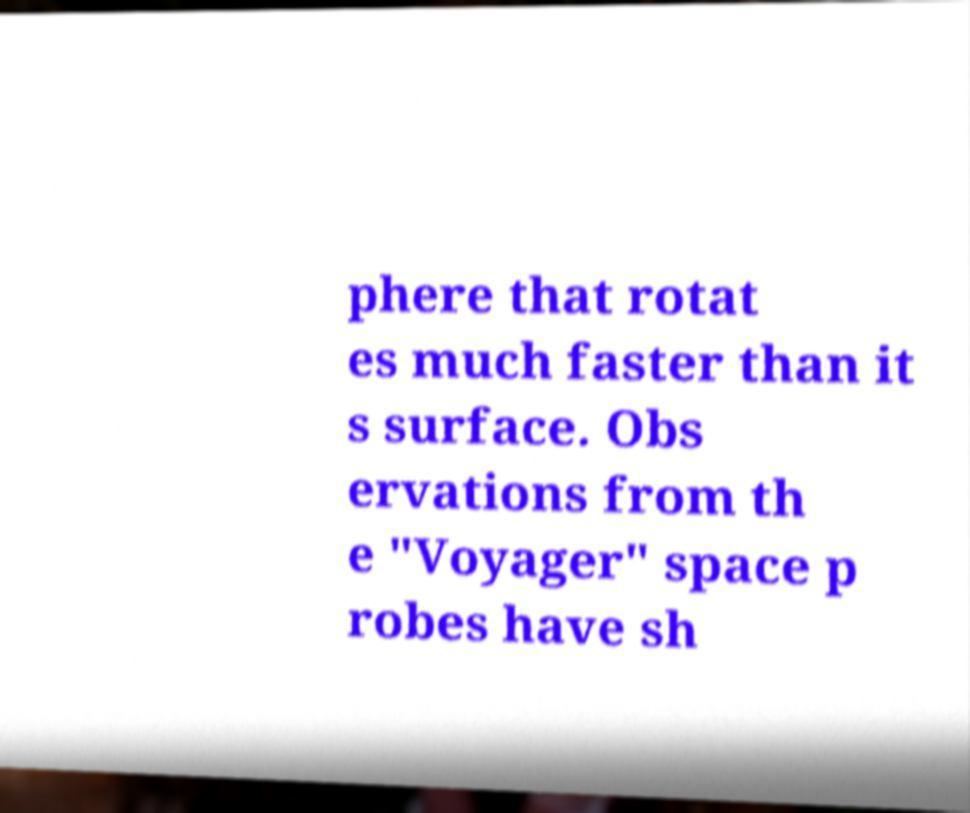Can you read and provide the text displayed in the image?This photo seems to have some interesting text. Can you extract and type it out for me? phere that rotat es much faster than it s surface. Obs ervations from th e "Voyager" space p robes have sh 